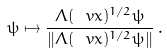Convert formula to latex. <formula><loc_0><loc_0><loc_500><loc_500>\psi \mapsto \frac { \Lambda ( \ v x ) ^ { 1 / 2 } \psi } { \| \Lambda ( \ v x ) ^ { 1 / 2 } \psi \| } \, .</formula> 